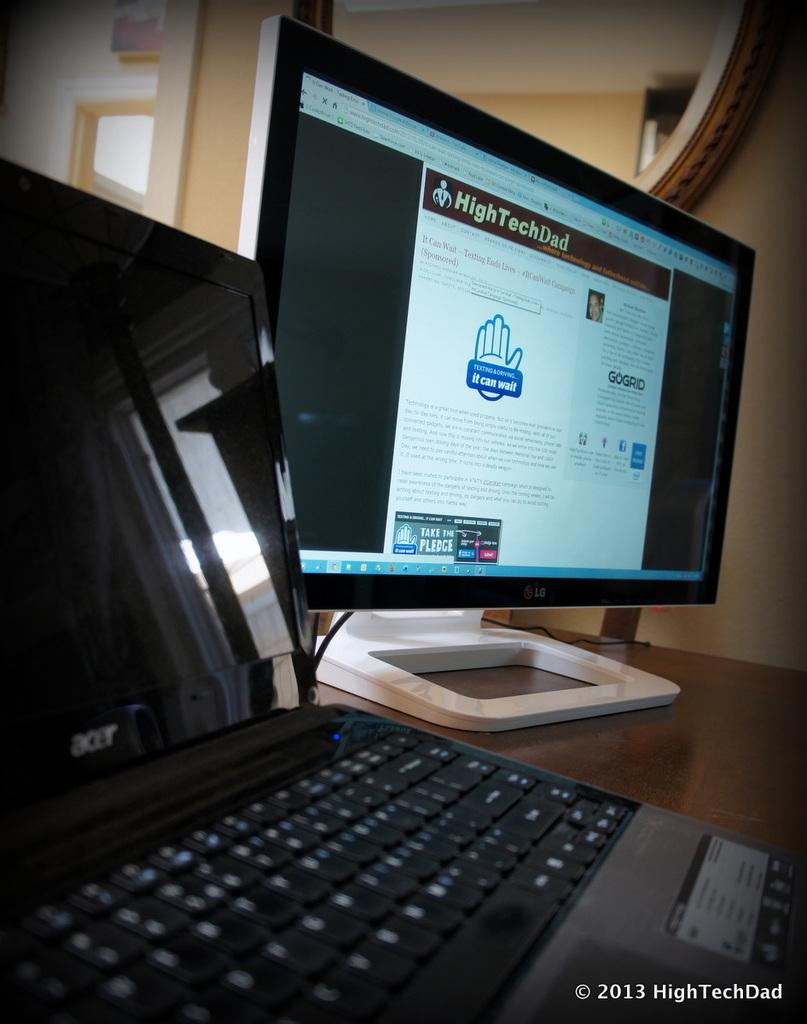What electronic device is visible in the image? There is a laptop in the image. What other electronic device can be seen in the image? There is a monitor in the image. Where are the laptop and monitor located? Both the laptop and monitor are on a table. Is there any additional information or marking on the image? Yes, there is a watermark at the right bottom of the image. Can you see a kitty resting on the laptop in the image? No, there is no kitty present in the image. How many times does the person in the image jump while using the laptop? There is no person visible in the image, and therefore no jumping can be observed. 